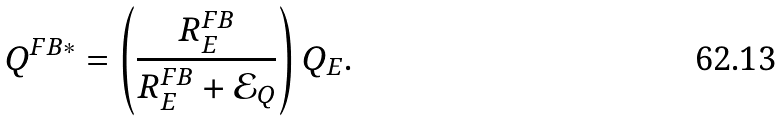<formula> <loc_0><loc_0><loc_500><loc_500>Q ^ { F B * } = \left ( \frac { R ^ { F B } _ { E } } { R ^ { F B } _ { E } + \mathcal { E } _ { Q } } \right ) Q _ { E } .</formula> 